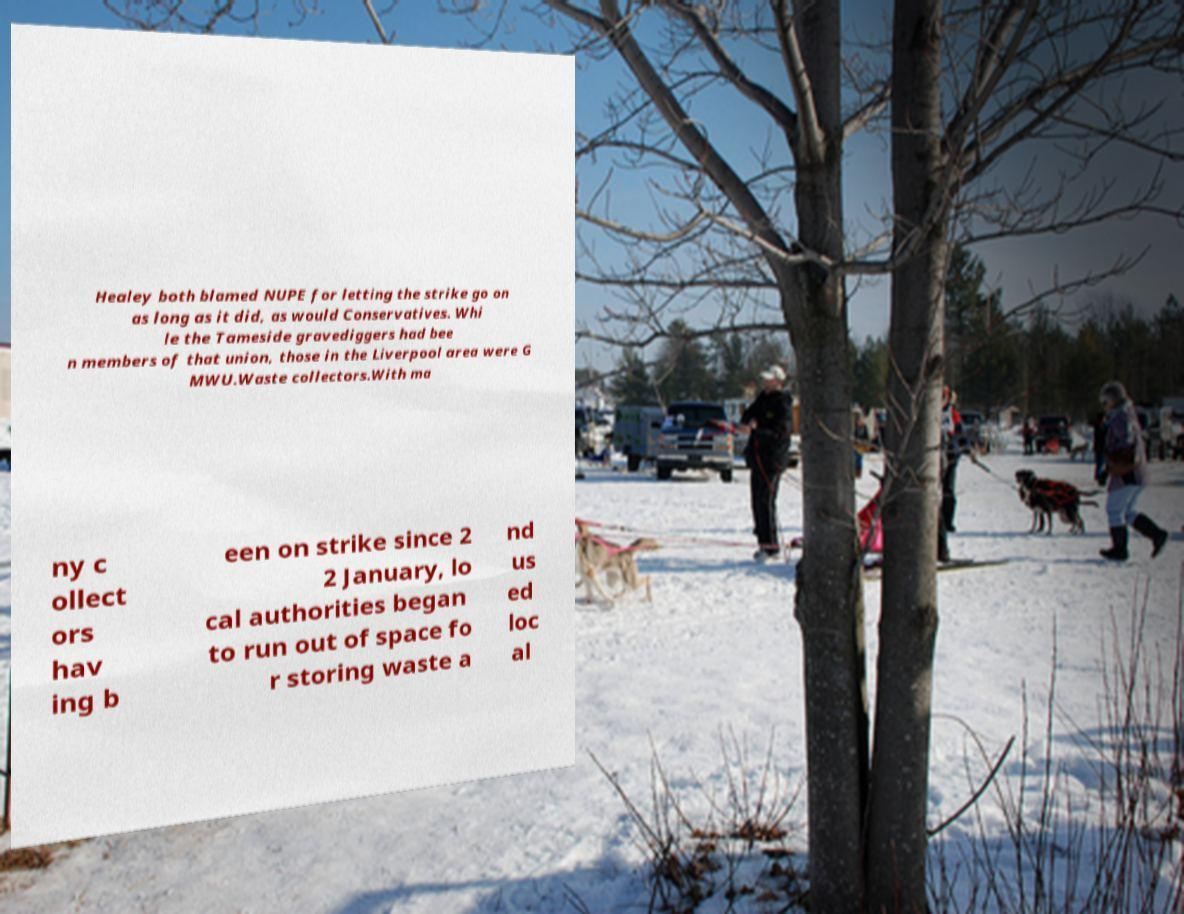For documentation purposes, I need the text within this image transcribed. Could you provide that? Healey both blamed NUPE for letting the strike go on as long as it did, as would Conservatives. Whi le the Tameside gravediggers had bee n members of that union, those in the Liverpool area were G MWU.Waste collectors.With ma ny c ollect ors hav ing b een on strike since 2 2 January, lo cal authorities began to run out of space fo r storing waste a nd us ed loc al 